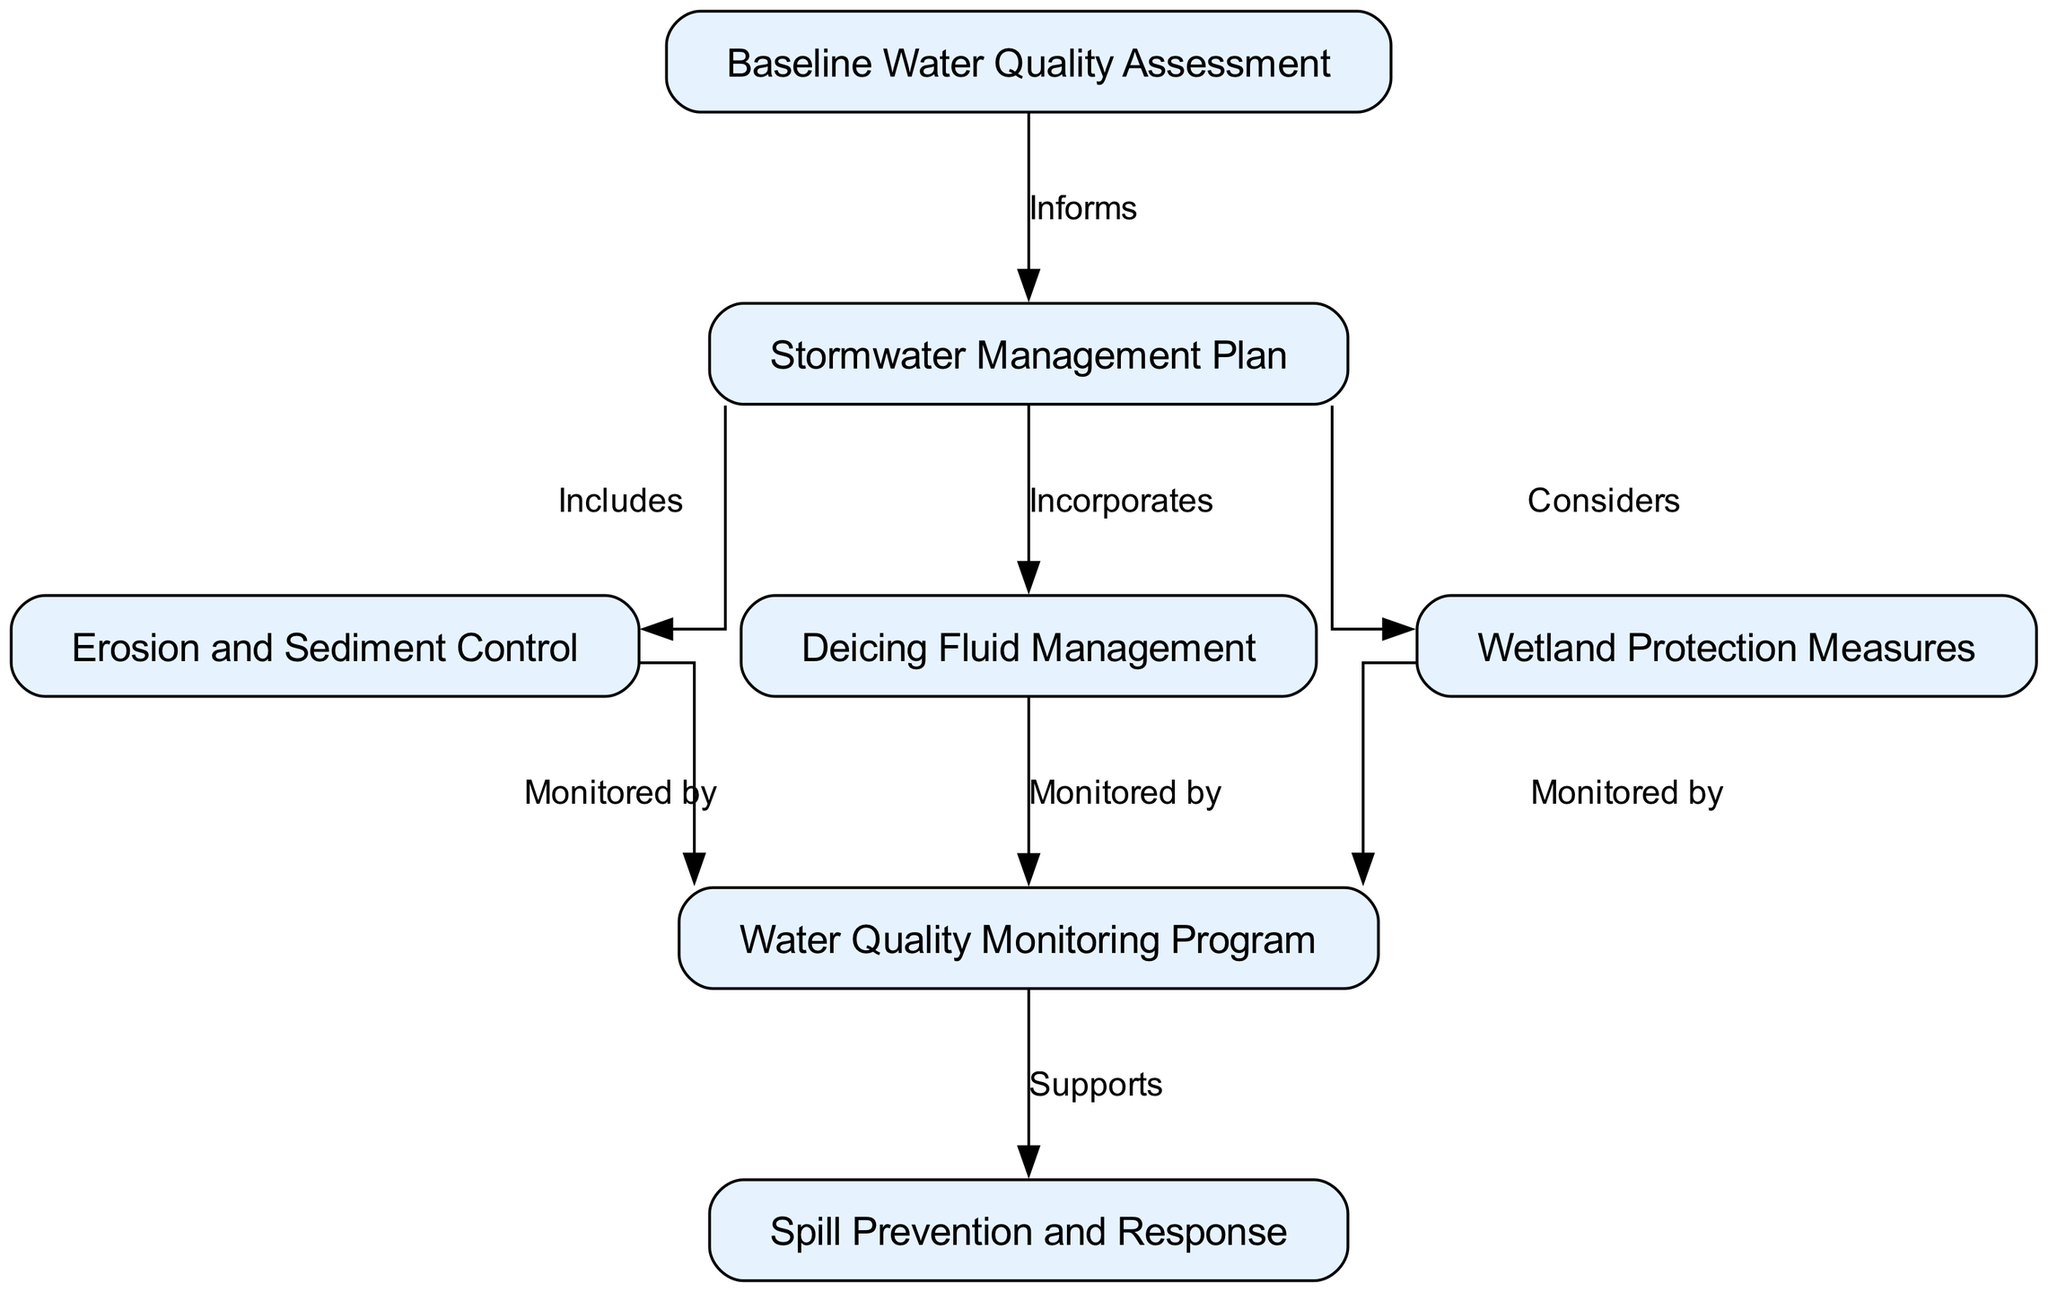What is the first step in the pathway? The first node in the pathway is "Baseline Water Quality Assessment" which indicates the initial step before any management actions are taken.
Answer: Baseline Water Quality Assessment How many nodes are there in the diagram? Counting the nodes listed in the data, there are 7 distinct nodes present in the diagram.
Answer: 7 What does the Stormwater Management Plan include? The "Stormwater Management Plan" includes the "Erosion and Sediment Control" as indicated by the relationship from node 2 to node 3 labeled as "Includes".
Answer: Erosion and Sediment Control Which measure is monitored by all management plans? The "Water Quality Monitoring Program" is monitored by the "Erosion and Sediment Control", "Deicing Fluid Management", and "Wetland Protection Measures". This can be derived from the connections from nodes 3, 4, and 5 to node 6.
Answer: Water Quality Monitoring Program What supports the Spill Prevention and Response? The "Water Quality Monitoring Program" supports the "Spill Prevention and Response" as shown by the arrow from node 6 to node 7 labeled as "Supports".
Answer: Water Quality Monitoring Program Which plan considers wetland protection? The "Stormwater Management Plan" considers wetland protection as indicated by the relationship from node 2 to node 5 labeled as "Considers".
Answer: Wetland Protection Measures How many edges are noted in the diagram? There are 8 edges represented in the diagram that describe relationships between the nodes.
Answer: 8 What is the relationship between deicing fluid management and water quality monitoring? The "Deicing Fluid Management" is monitored by the "Water Quality Monitoring Program", which signifies a link where the monitoring program tracks the impact of deicing fluids on water quality.
Answer: Monitored by 